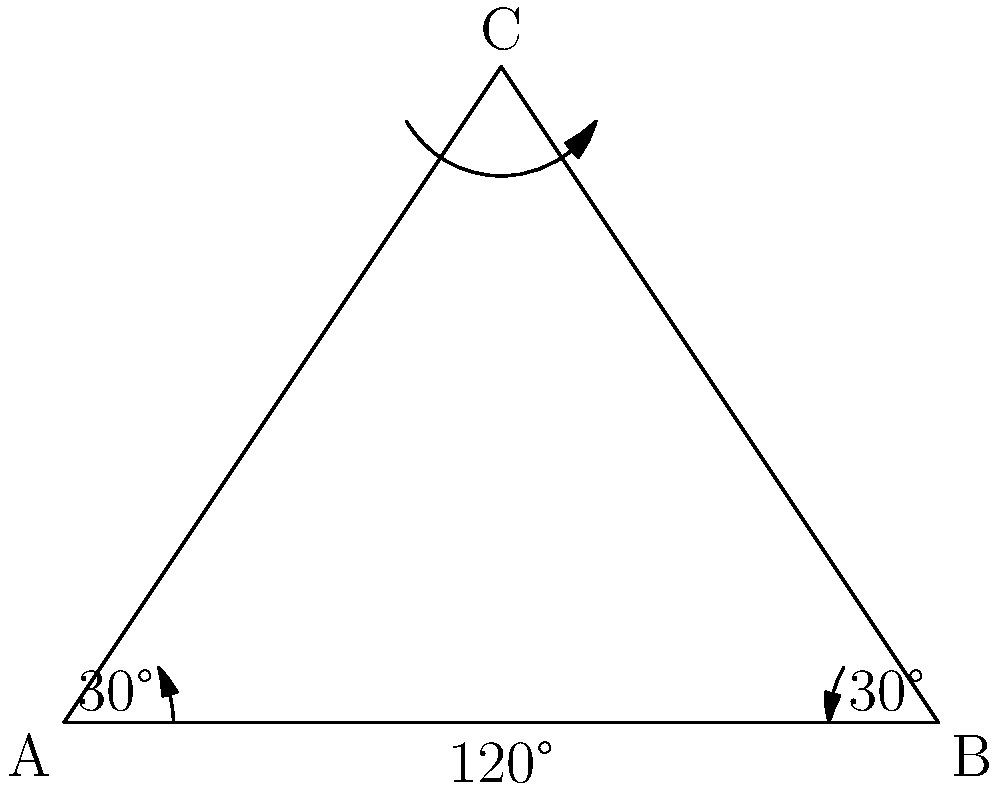A surveillance camera is positioned at point C, overlooking a restricted area represented by triangle ABC. The camera's field of view is 120°, covering the entire base of the triangle (AB). If the angles at both A and B are 30°, what is the measure of angle ACB? Let's approach this step-by-step:

1) In any triangle, the sum of all internal angles is always 180°.

2) We are given that:
   - Angle CAB = 30°
   - Angle CBA = 30°
   - Angle ACB is what we need to find

3) Let's call angle ACB as x°.

4) Using the triangle angle sum theorem:
   $$30° + 30° + x° = 180°$$

5) Simplifying:
   $$60° + x° = 180°$$

6) Subtracting 60° from both sides:
   $$x° = 180° - 60° = 120°$$

7) Therefore, angle ACB measures 120°.

8) This aligns with the given information that the camera's field of view is 120°, covering the entire base of the triangle.
Answer: 120° 